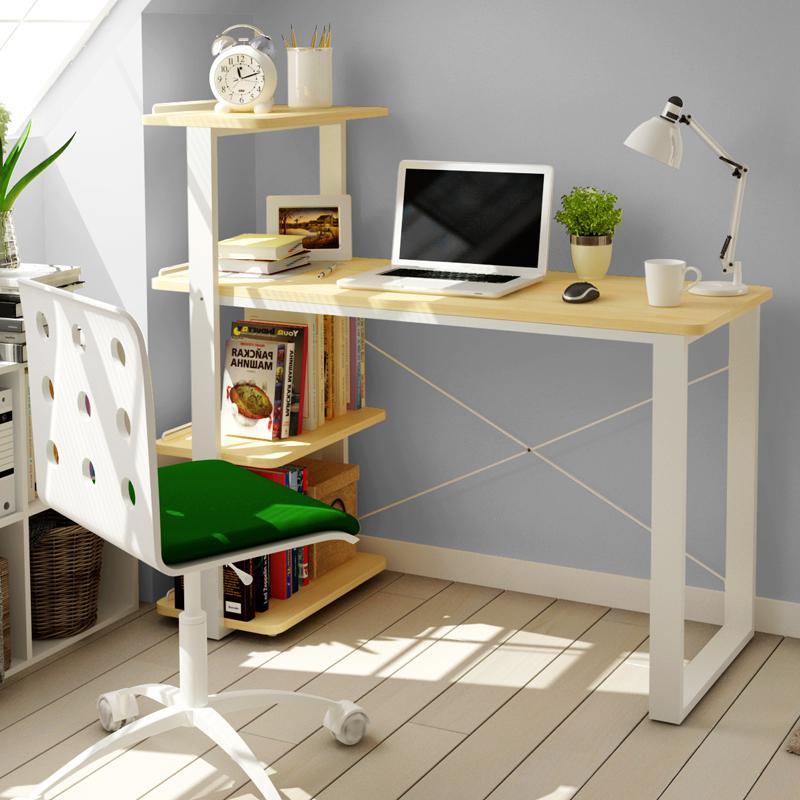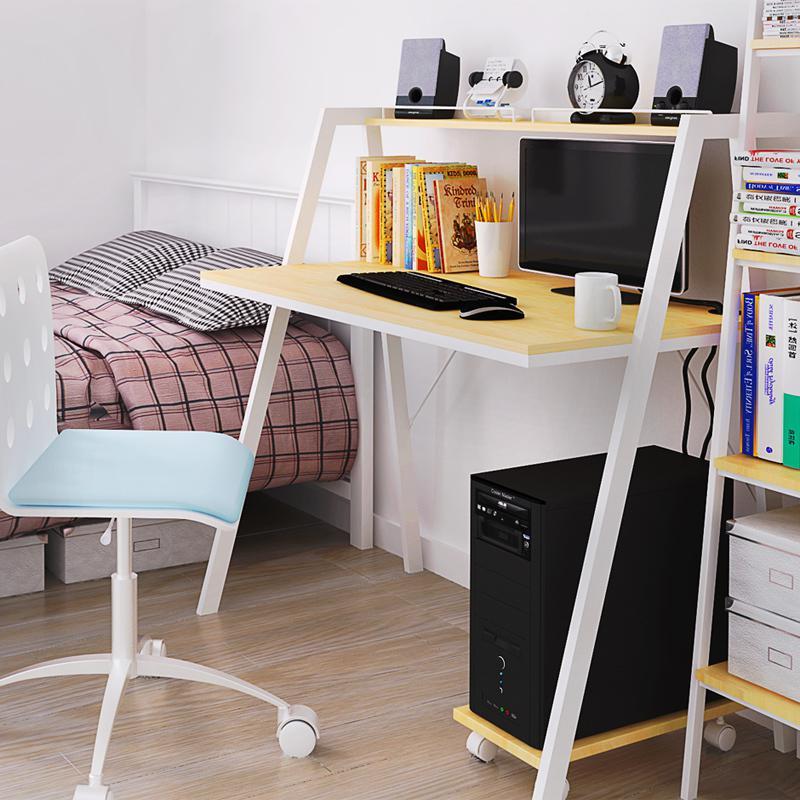The first image is the image on the left, the second image is the image on the right. Assess this claim about the two images: "There is a total of 1 flower-less, green, leafy plant sitting to the right of a laptop screen.". Correct or not? Answer yes or no. Yes. The first image is the image on the left, the second image is the image on the right. For the images displayed, is the sentence "Both sides of the desk are actually book shelves." factually correct? Answer yes or no. No. 